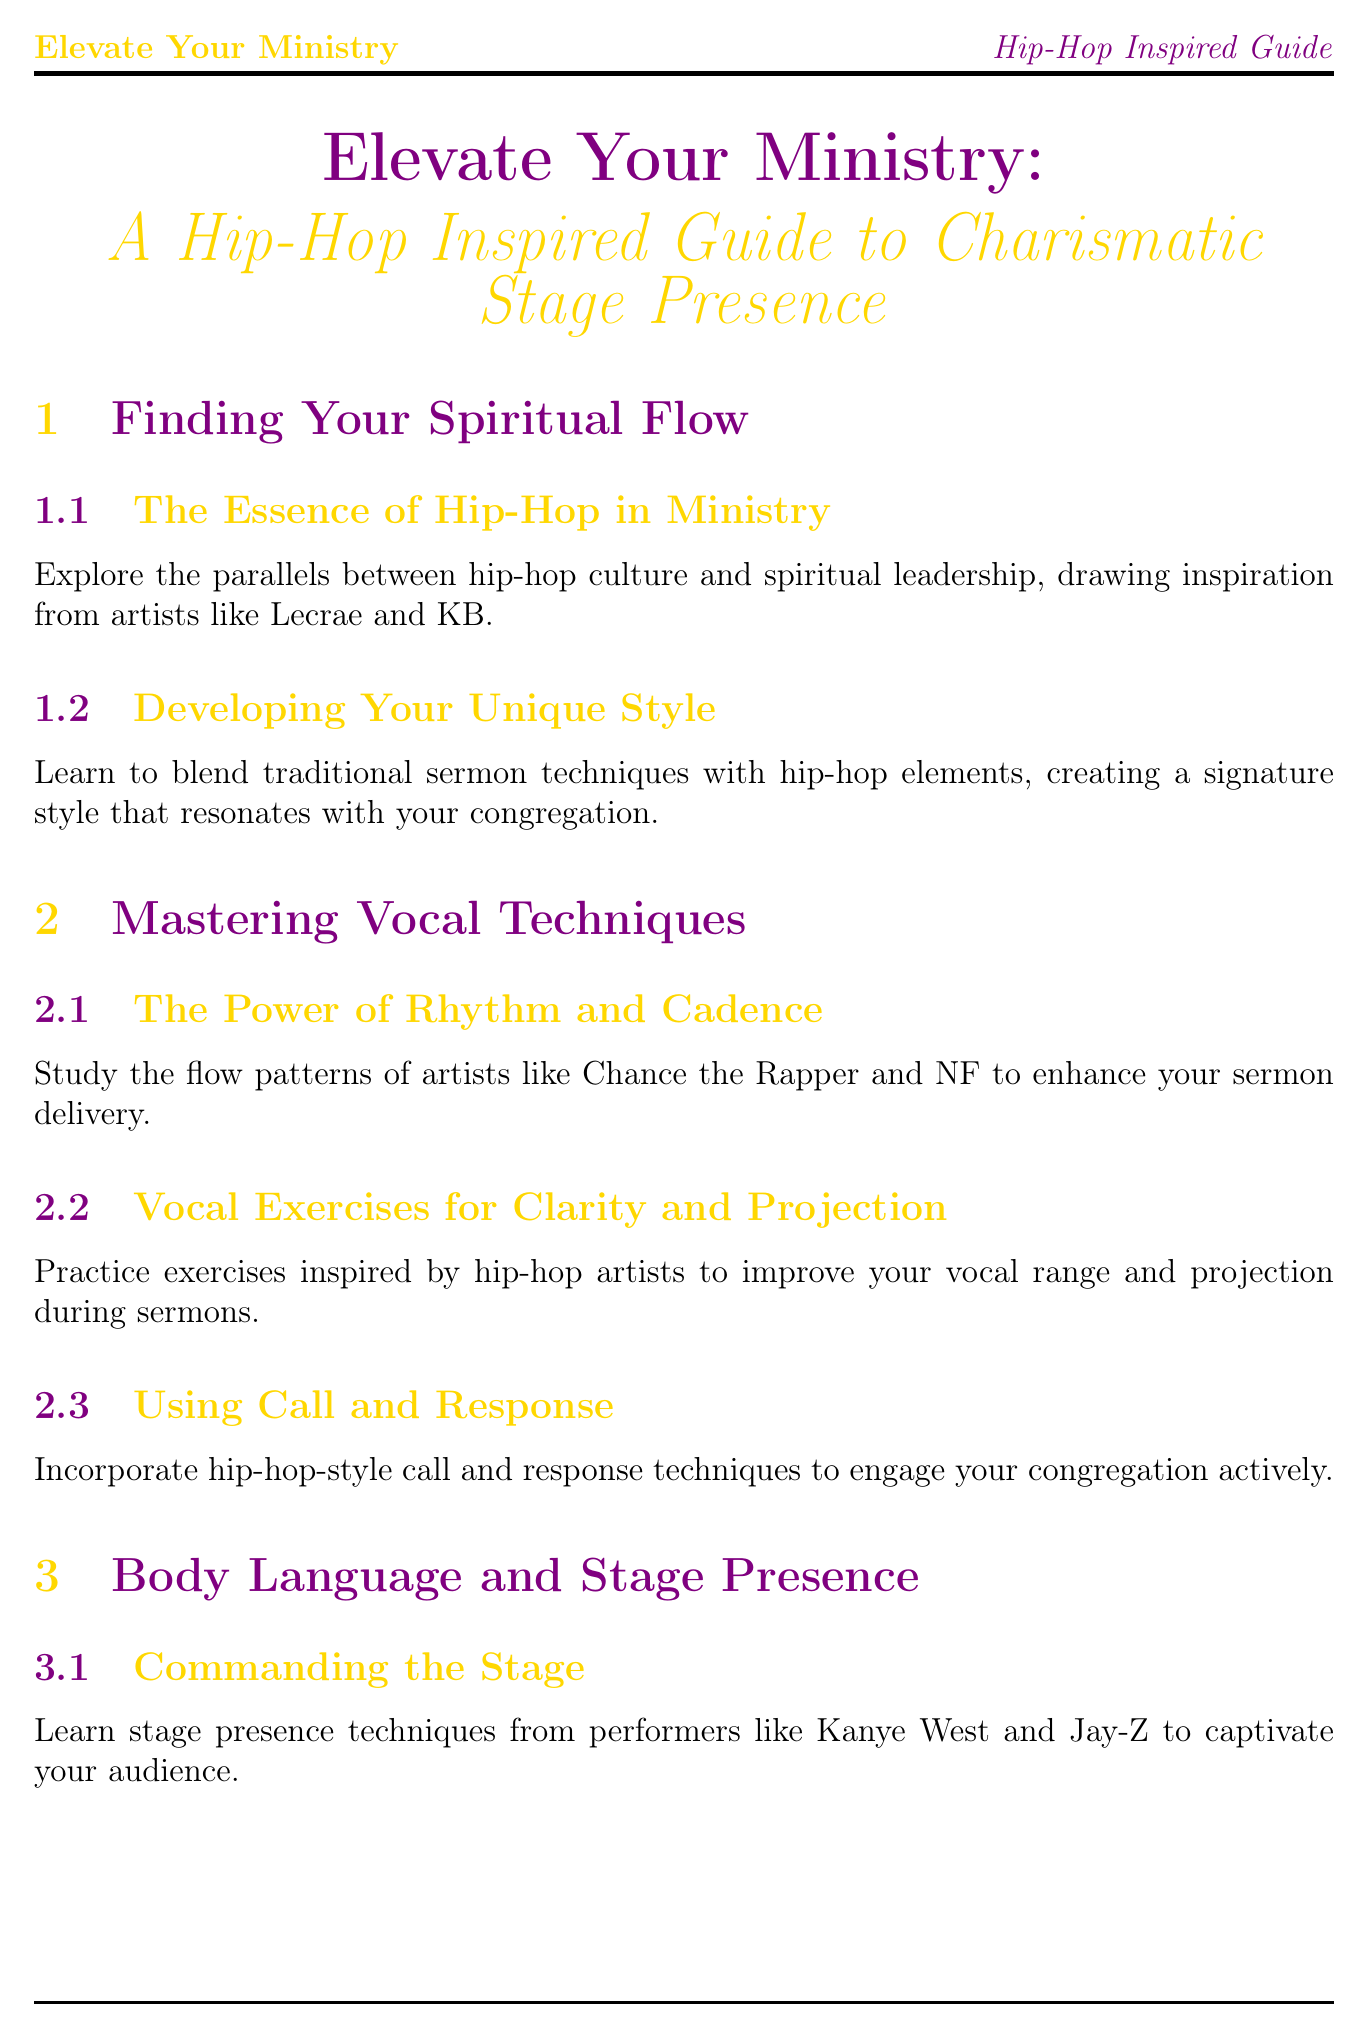What is the title of the manual? The title is clearly stated at the beginning of the document.
Answer: Elevate Your Ministry: A Hip-Hop Inspired Guide to Charismatic Stage Presence Who are two hip-hop artists mentioned in the chapter "Finding Your Spiritual Flow"? The section lists two prominent hip-hop artists as examples of inspiration for ministry.
Answer: Lecrae and KB How many sections are in the chapter “Mastering Vocal Techniques”? By counting the sections listed under this chapter, you can determine the total number.
Answer: 3 What kind of techniques does the section "Using Call and Response" discuss? This section describes a specific type of engagement technique used in hip-hop that can enhance sermons.
Answer: Hip-hop-style call and response techniques Which chapter addresses strategies for social media presence? Identifying the chapter that discusses online engagement and social media strategies is essential.
Answer: Technology and Production What is the focus of the section titled "Continuous Learning and Growth"? This section emphasizes the importance of adapting and evolving in both spiritual and cultural contexts.
Answer: Staying current with both spiritual teachings and hip-hop culture From which performance style should you learn to engage an audience? The document suggests looking to a specific type of entertainment to enhance stage presence.
Answer: Performers like Kanye West and Jay-Z What primary narrative styles are emphasized for impactful sermons? Understanding storytelling methods specific to hip-hop helps in sermon crafting.
Answer: Hip-hop's narrative traditions 